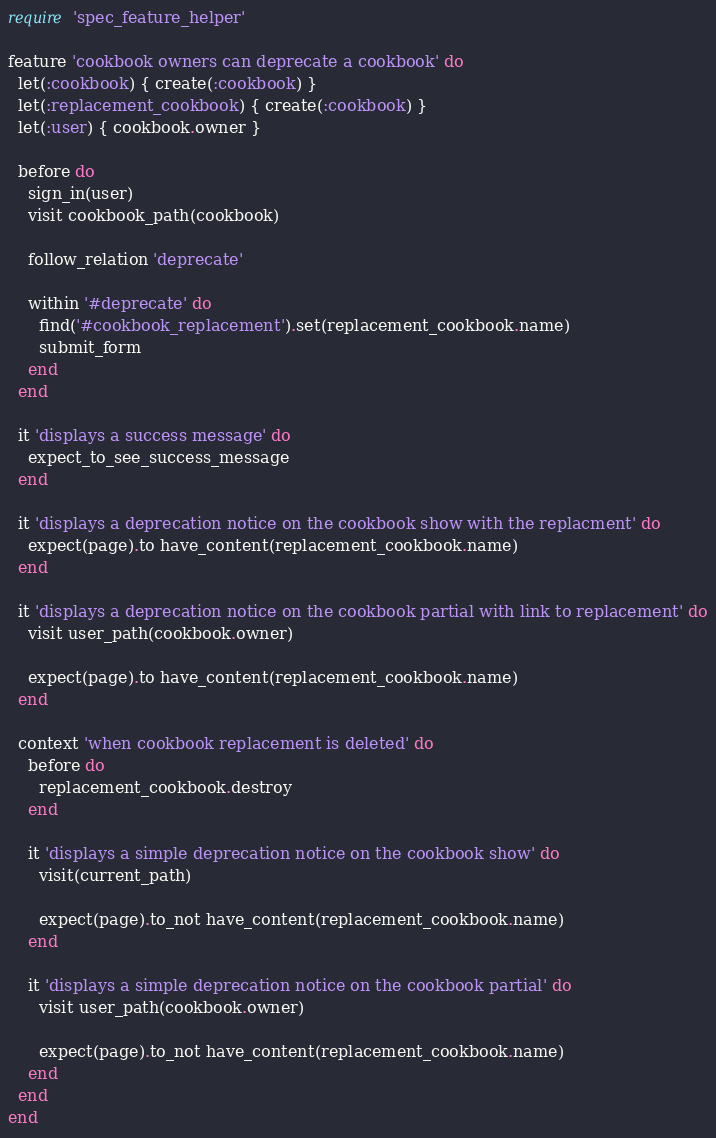Convert code to text. <code><loc_0><loc_0><loc_500><loc_500><_Ruby_>require 'spec_feature_helper'

feature 'cookbook owners can deprecate a cookbook' do
  let(:cookbook) { create(:cookbook) }
  let(:replacement_cookbook) { create(:cookbook) }
  let(:user) { cookbook.owner }

  before do
    sign_in(user)
    visit cookbook_path(cookbook)

    follow_relation 'deprecate'

    within '#deprecate' do
      find('#cookbook_replacement').set(replacement_cookbook.name)
      submit_form
    end
  end

  it 'displays a success message' do
    expect_to_see_success_message
  end

  it 'displays a deprecation notice on the cookbook show with the replacment' do
    expect(page).to have_content(replacement_cookbook.name)
  end

  it 'displays a deprecation notice on the cookbook partial with link to replacement' do
    visit user_path(cookbook.owner)

    expect(page).to have_content(replacement_cookbook.name)
  end

  context 'when cookbook replacement is deleted' do
    before do
      replacement_cookbook.destroy
    end

    it 'displays a simple deprecation notice on the cookbook show' do
      visit(current_path)

      expect(page).to_not have_content(replacement_cookbook.name)
    end

    it 'displays a simple deprecation notice on the cookbook partial' do
      visit user_path(cookbook.owner)

      expect(page).to_not have_content(replacement_cookbook.name)
    end
  end
end
</code> 